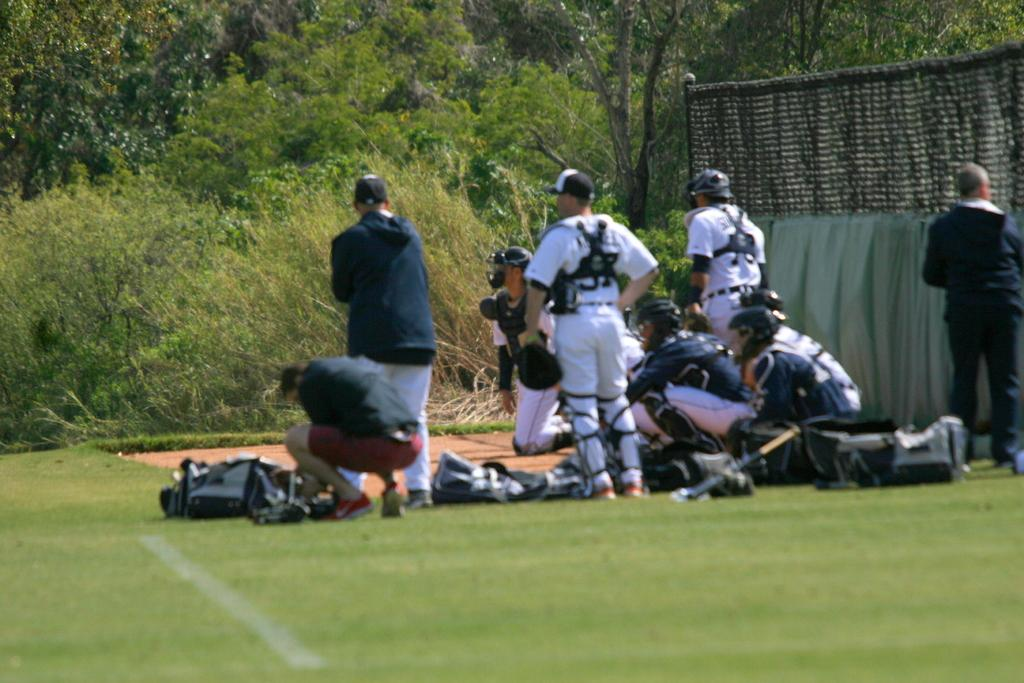What are the people in the image doing? The people in the image are standing on the ground. What objects can be seen near the people? There are bags visible in the image. What is the purpose of the net in the image? The purpose of the net in the image is not clear, but it could be used for sports or other activities. What can be seen in the background of the image? Trees are present in the background of the image. What type of wine is being served in the image? There is no wine present in the image; it features people standing on the ground with bags and a net, along with trees in the background. 